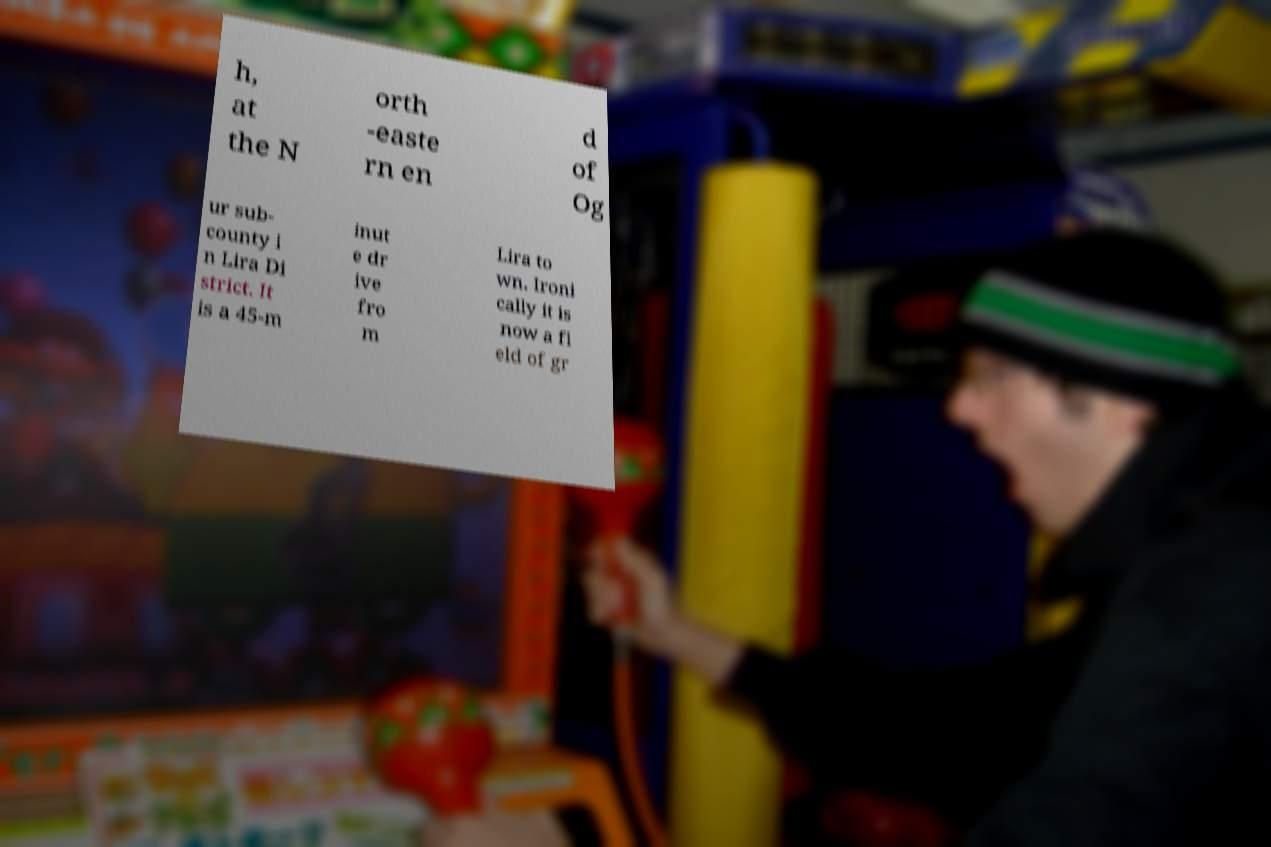For documentation purposes, I need the text within this image transcribed. Could you provide that? h, at the N orth -easte rn en d of Og ur sub- county i n Lira Di strict. It is a 45-m inut e dr ive fro m Lira to wn. Ironi cally it is now a fi eld of gr 